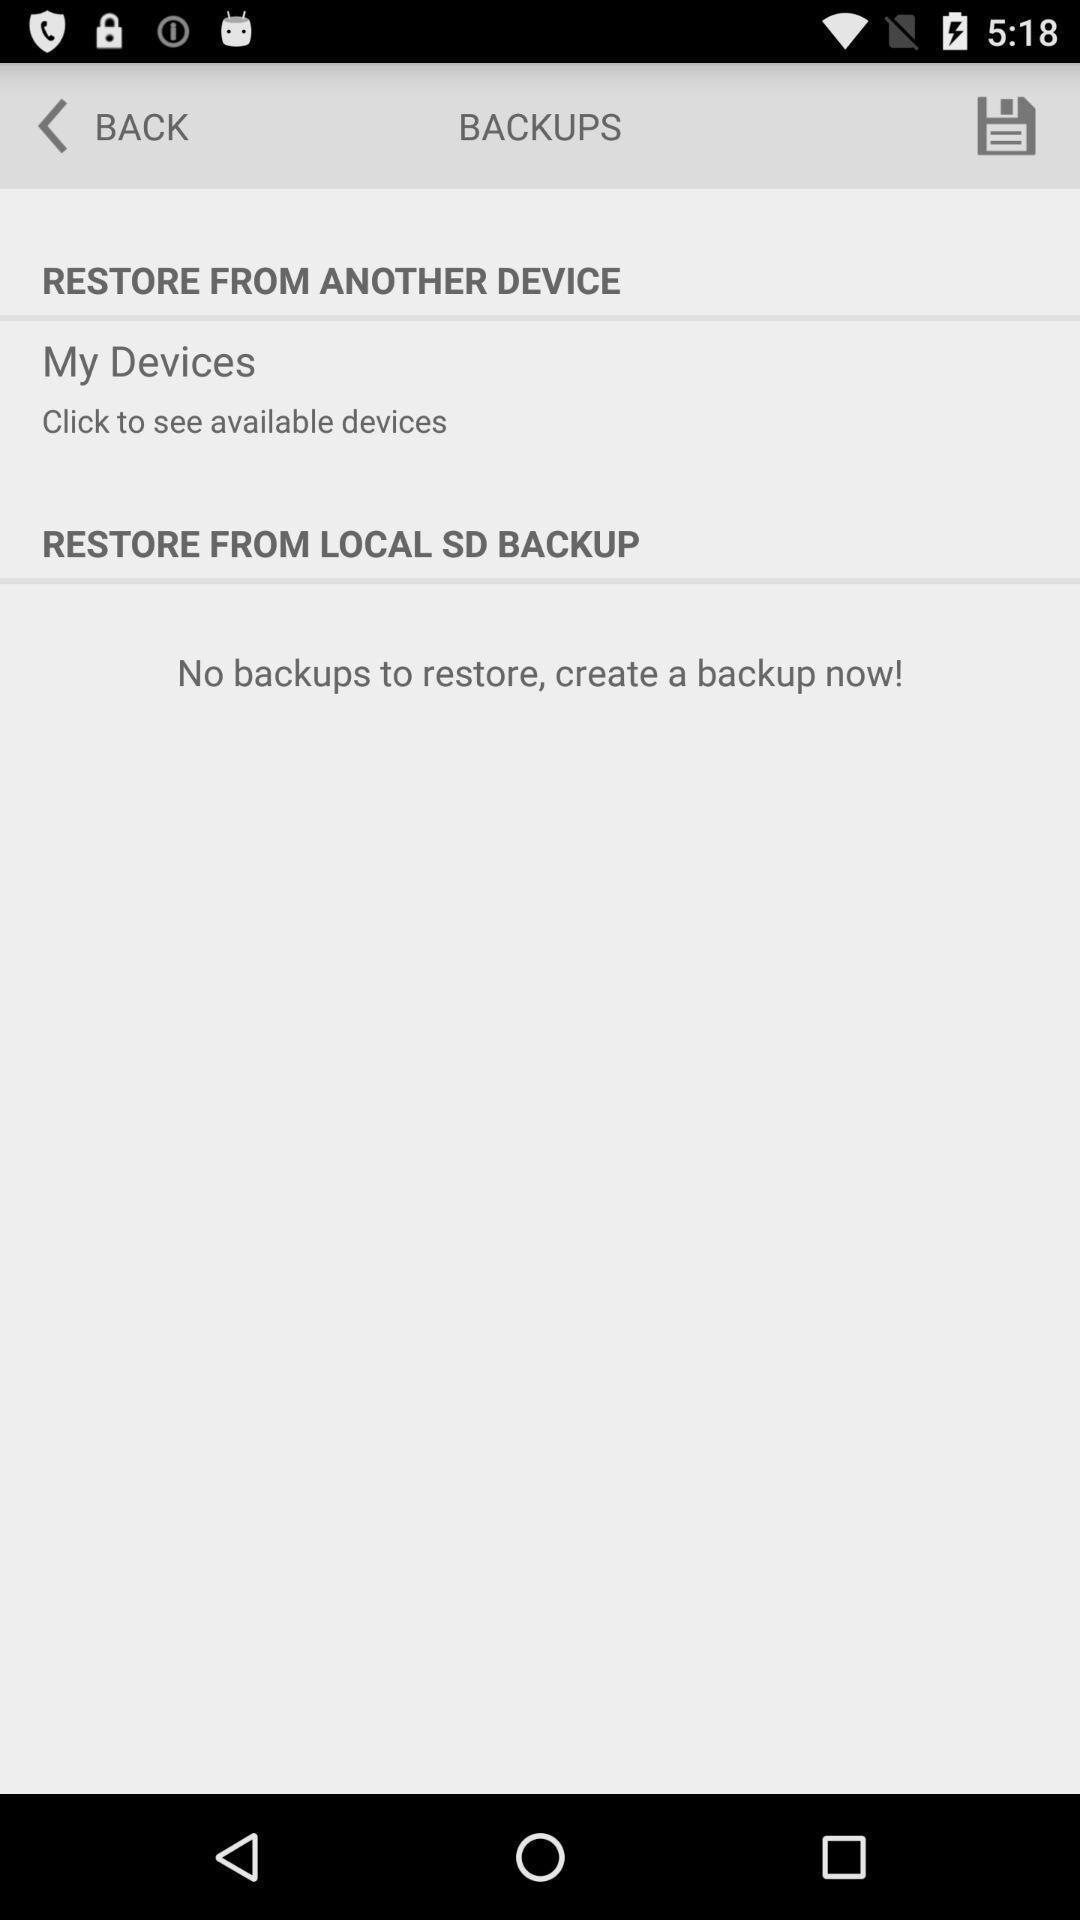Give me a narrative description of this picture. Page displaying with restore settings and options. 